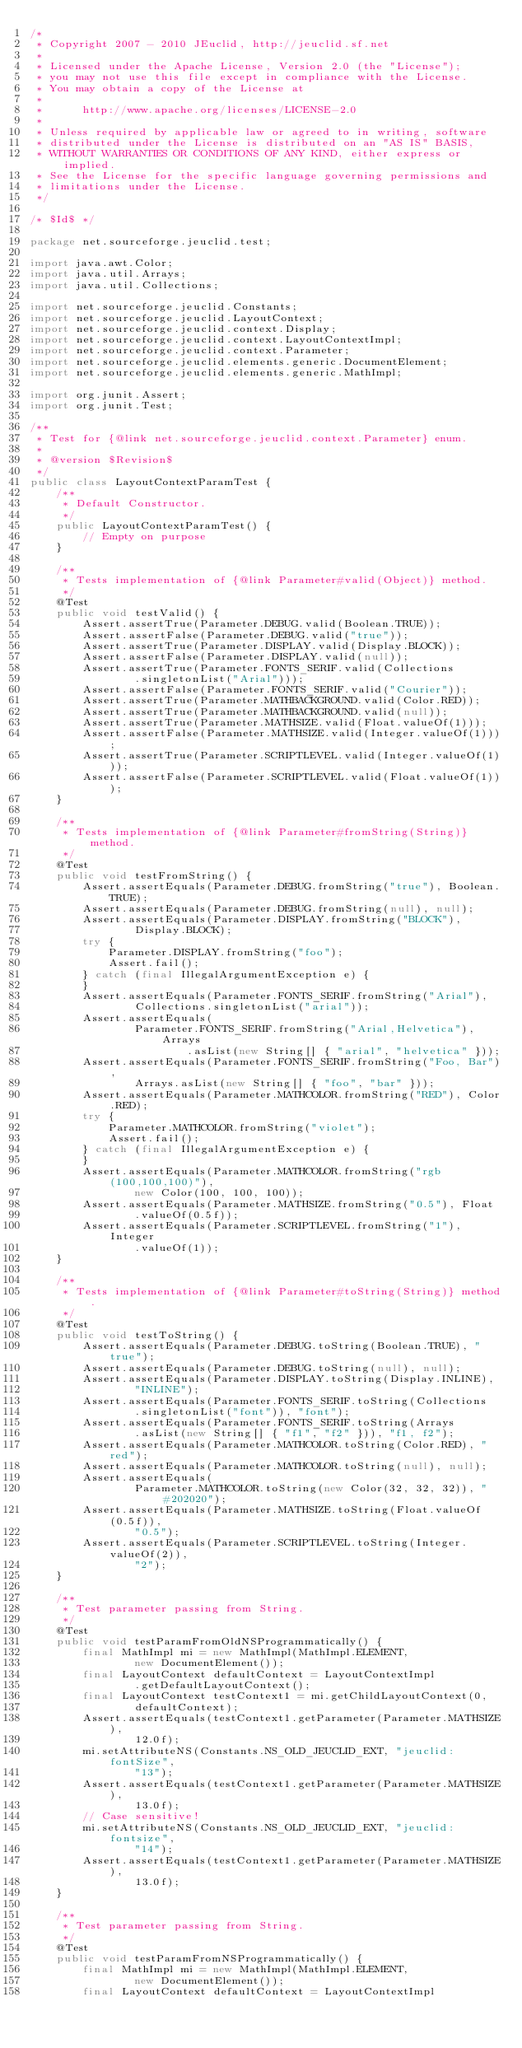<code> <loc_0><loc_0><loc_500><loc_500><_Java_>/*
 * Copyright 2007 - 2010 JEuclid, http://jeuclid.sf.net
 *
 * Licensed under the Apache License, Version 2.0 (the "License");
 * you may not use this file except in compliance with the License.
 * You may obtain a copy of the License at
 *
 *      http://www.apache.org/licenses/LICENSE-2.0
 *
 * Unless required by applicable law or agreed to in writing, software
 * distributed under the License is distributed on an "AS IS" BASIS,
 * WITHOUT WARRANTIES OR CONDITIONS OF ANY KIND, either express or implied.
 * See the License for the specific language governing permissions and
 * limitations under the License.
 */

/* $Id$ */

package net.sourceforge.jeuclid.test;

import java.awt.Color;
import java.util.Arrays;
import java.util.Collections;

import net.sourceforge.jeuclid.Constants;
import net.sourceforge.jeuclid.LayoutContext;
import net.sourceforge.jeuclid.context.Display;
import net.sourceforge.jeuclid.context.LayoutContextImpl;
import net.sourceforge.jeuclid.context.Parameter;
import net.sourceforge.jeuclid.elements.generic.DocumentElement;
import net.sourceforge.jeuclid.elements.generic.MathImpl;

import org.junit.Assert;
import org.junit.Test;

/**
 * Test for {@link net.sourceforge.jeuclid.context.Parameter} enum.
 *
 * @version $Revision$
 */
public class LayoutContextParamTest {
    /**
     * Default Constructor.
     */
    public LayoutContextParamTest() {
        // Empty on purpose
    }

    /**
     * Tests implementation of {@link Parameter#valid(Object)} method.
     */
    @Test
    public void testValid() {
        Assert.assertTrue(Parameter.DEBUG.valid(Boolean.TRUE));
        Assert.assertFalse(Parameter.DEBUG.valid("true"));
        Assert.assertTrue(Parameter.DISPLAY.valid(Display.BLOCK));
        Assert.assertFalse(Parameter.DISPLAY.valid(null));
        Assert.assertTrue(Parameter.FONTS_SERIF.valid(Collections
                .singletonList("Arial")));
        Assert.assertFalse(Parameter.FONTS_SERIF.valid("Courier"));
        Assert.assertTrue(Parameter.MATHBACKGROUND.valid(Color.RED));
        Assert.assertTrue(Parameter.MATHBACKGROUND.valid(null));
        Assert.assertTrue(Parameter.MATHSIZE.valid(Float.valueOf(1)));
        Assert.assertFalse(Parameter.MATHSIZE.valid(Integer.valueOf(1)));
        Assert.assertTrue(Parameter.SCRIPTLEVEL.valid(Integer.valueOf(1)));
        Assert.assertFalse(Parameter.SCRIPTLEVEL.valid(Float.valueOf(1)));
    }

    /**
     * Tests implementation of {@link Parameter#fromString(String)} method.
     */
    @Test
    public void testFromString() {
        Assert.assertEquals(Parameter.DEBUG.fromString("true"), Boolean.TRUE);
        Assert.assertEquals(Parameter.DEBUG.fromString(null), null);
        Assert.assertEquals(Parameter.DISPLAY.fromString("BLOCK"),
                Display.BLOCK);
        try {
            Parameter.DISPLAY.fromString("foo");
            Assert.fail();
        } catch (final IllegalArgumentException e) {
        }
        Assert.assertEquals(Parameter.FONTS_SERIF.fromString("Arial"),
                Collections.singletonList("arial"));
        Assert.assertEquals(
                Parameter.FONTS_SERIF.fromString("Arial,Helvetica"), Arrays
                        .asList(new String[] { "arial", "helvetica" }));
        Assert.assertEquals(Parameter.FONTS_SERIF.fromString("Foo, Bar"),
                Arrays.asList(new String[] { "foo", "bar" }));
        Assert.assertEquals(Parameter.MATHCOLOR.fromString("RED"), Color.RED);
        try {
            Parameter.MATHCOLOR.fromString("violet");
            Assert.fail();
        } catch (final IllegalArgumentException e) {
        }
        Assert.assertEquals(Parameter.MATHCOLOR.fromString("rgb(100,100,100)"),
                new Color(100, 100, 100));
        Assert.assertEquals(Parameter.MATHSIZE.fromString("0.5"), Float
                .valueOf(0.5f));
        Assert.assertEquals(Parameter.SCRIPTLEVEL.fromString("1"), Integer
                .valueOf(1));
    }

    /**
     * Tests implementation of {@link Parameter#toString(String)} method.
     */
    @Test
    public void testToString() {
        Assert.assertEquals(Parameter.DEBUG.toString(Boolean.TRUE), "true");
        Assert.assertEquals(Parameter.DEBUG.toString(null), null);
        Assert.assertEquals(Parameter.DISPLAY.toString(Display.INLINE),
                "INLINE");
        Assert.assertEquals(Parameter.FONTS_SERIF.toString(Collections
                .singletonList("font")), "font");
        Assert.assertEquals(Parameter.FONTS_SERIF.toString(Arrays
                .asList(new String[] { "f1", "f2" })), "f1, f2");
        Assert.assertEquals(Parameter.MATHCOLOR.toString(Color.RED), "red");
        Assert.assertEquals(Parameter.MATHCOLOR.toString(null), null);
        Assert.assertEquals(
                Parameter.MATHCOLOR.toString(new Color(32, 32, 32)), "#202020");
        Assert.assertEquals(Parameter.MATHSIZE.toString(Float.valueOf(0.5f)),
                "0.5");
        Assert.assertEquals(Parameter.SCRIPTLEVEL.toString(Integer.valueOf(2)),
                "2");
    }

    /**
     * Test parameter passing from String.
     */
    @Test
    public void testParamFromOldNSProgrammatically() {
        final MathImpl mi = new MathImpl(MathImpl.ELEMENT,
                new DocumentElement());
        final LayoutContext defaultContext = LayoutContextImpl
                .getDefaultLayoutContext();
        final LayoutContext testContext1 = mi.getChildLayoutContext(0,
                defaultContext);
        Assert.assertEquals(testContext1.getParameter(Parameter.MATHSIZE),
                12.0f);
        mi.setAttributeNS(Constants.NS_OLD_JEUCLID_EXT, "jeuclid:fontSize",
                "13");
        Assert.assertEquals(testContext1.getParameter(Parameter.MATHSIZE),
                13.0f);
        // Case sensitive!
        mi.setAttributeNS(Constants.NS_OLD_JEUCLID_EXT, "jeuclid:fontsize",
                "14");
        Assert.assertEquals(testContext1.getParameter(Parameter.MATHSIZE),
                13.0f);
    }

    /**
     * Test parameter passing from String.
     */
    @Test
    public void testParamFromNSProgrammatically() {
        final MathImpl mi = new MathImpl(MathImpl.ELEMENT,
                new DocumentElement());
        final LayoutContext defaultContext = LayoutContextImpl</code> 